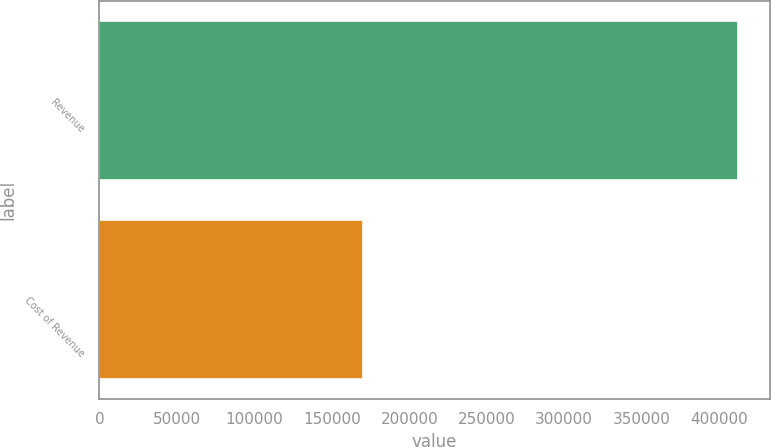Convert chart to OTSL. <chart><loc_0><loc_0><loc_500><loc_500><bar_chart><fcel>Revenue<fcel>Cost of Revenue<nl><fcel>412021<fcel>169793<nl></chart> 